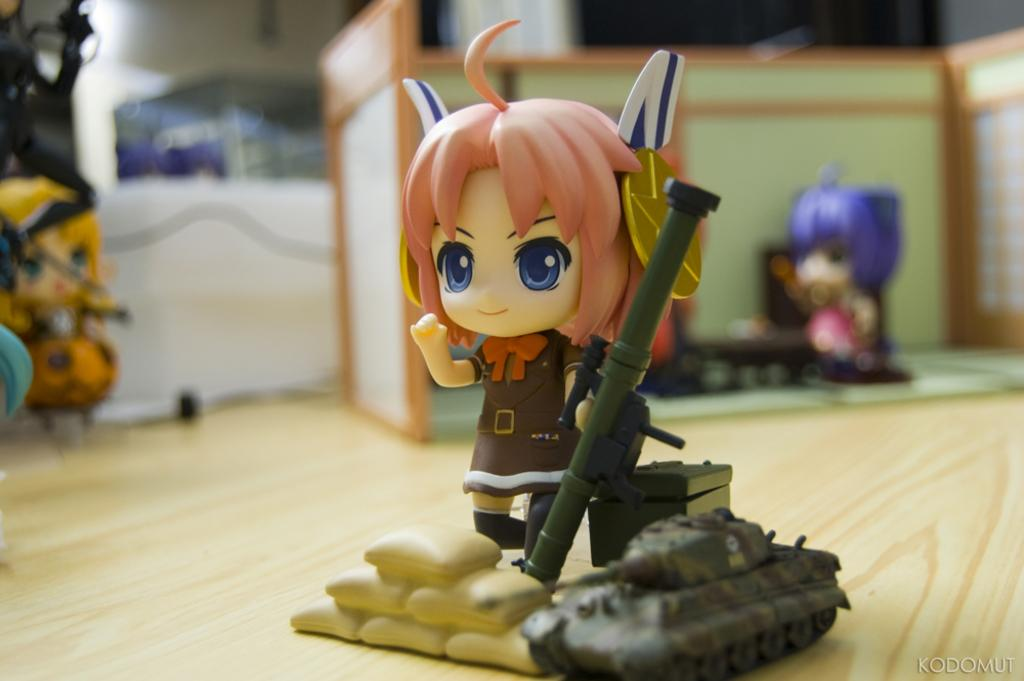What is the main subject in the center of the image? There are toys in the center of the image. Are there any other toys visible in the image? Yes, there are other toys in the background of the image. What can be seen in the background of the image besides toys? There is a wall in the background of the image. What part of the room is visible at the bottom of the image? The floor is visible at the bottom of the image. What type of crate is being used to store the crayons in the image? There is no crate or crayons present in the image. 